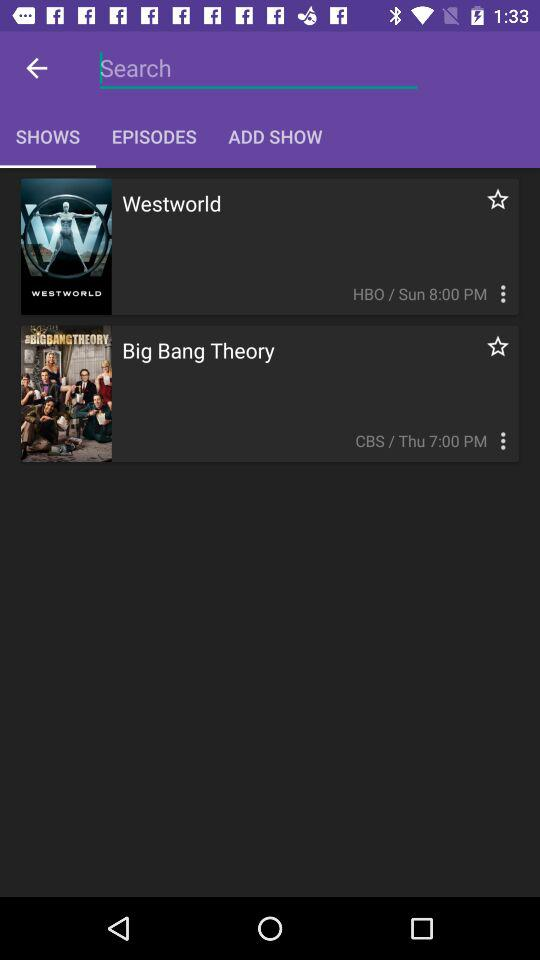What time does "Westworld" air? "Westworld" airs at 8:00 PM. 